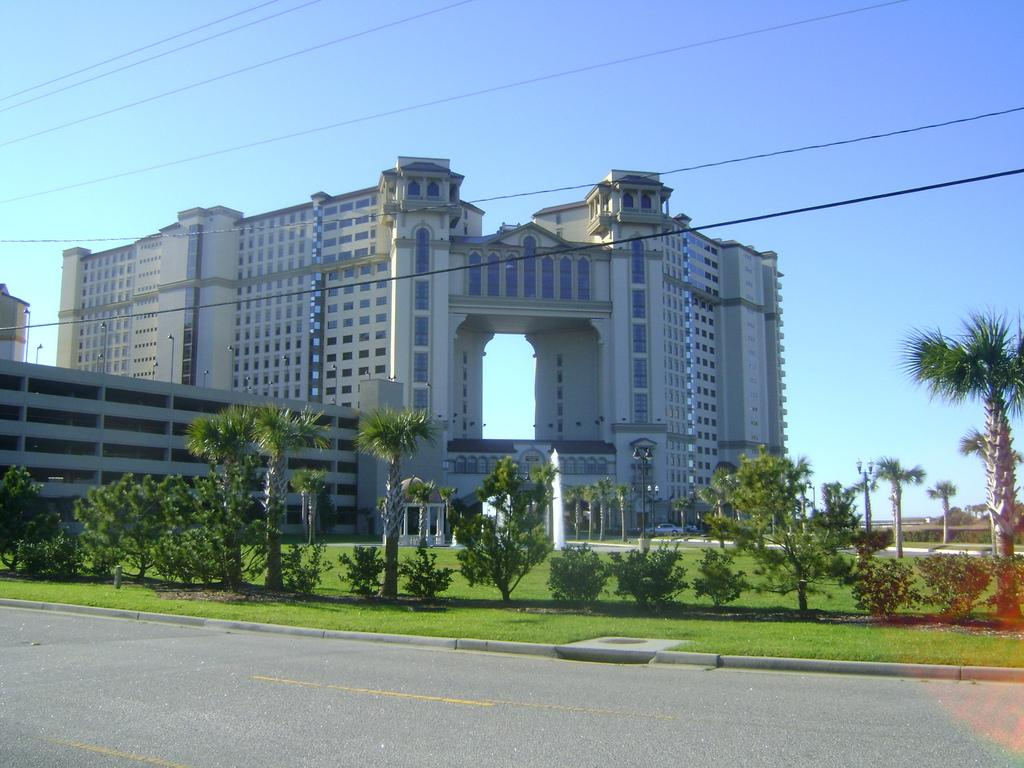What is the main feature of the image? There is a road in the image. What other elements can be seen alongside the road? There are plants, trees, poles, lights, buildings, and cables in the image. What is visible in the background of the image? The sky is visible in the background of the image. Where is the grandmother sitting with her pump and wood in the image? There is no grandmother, pump, or wood present in the image. 